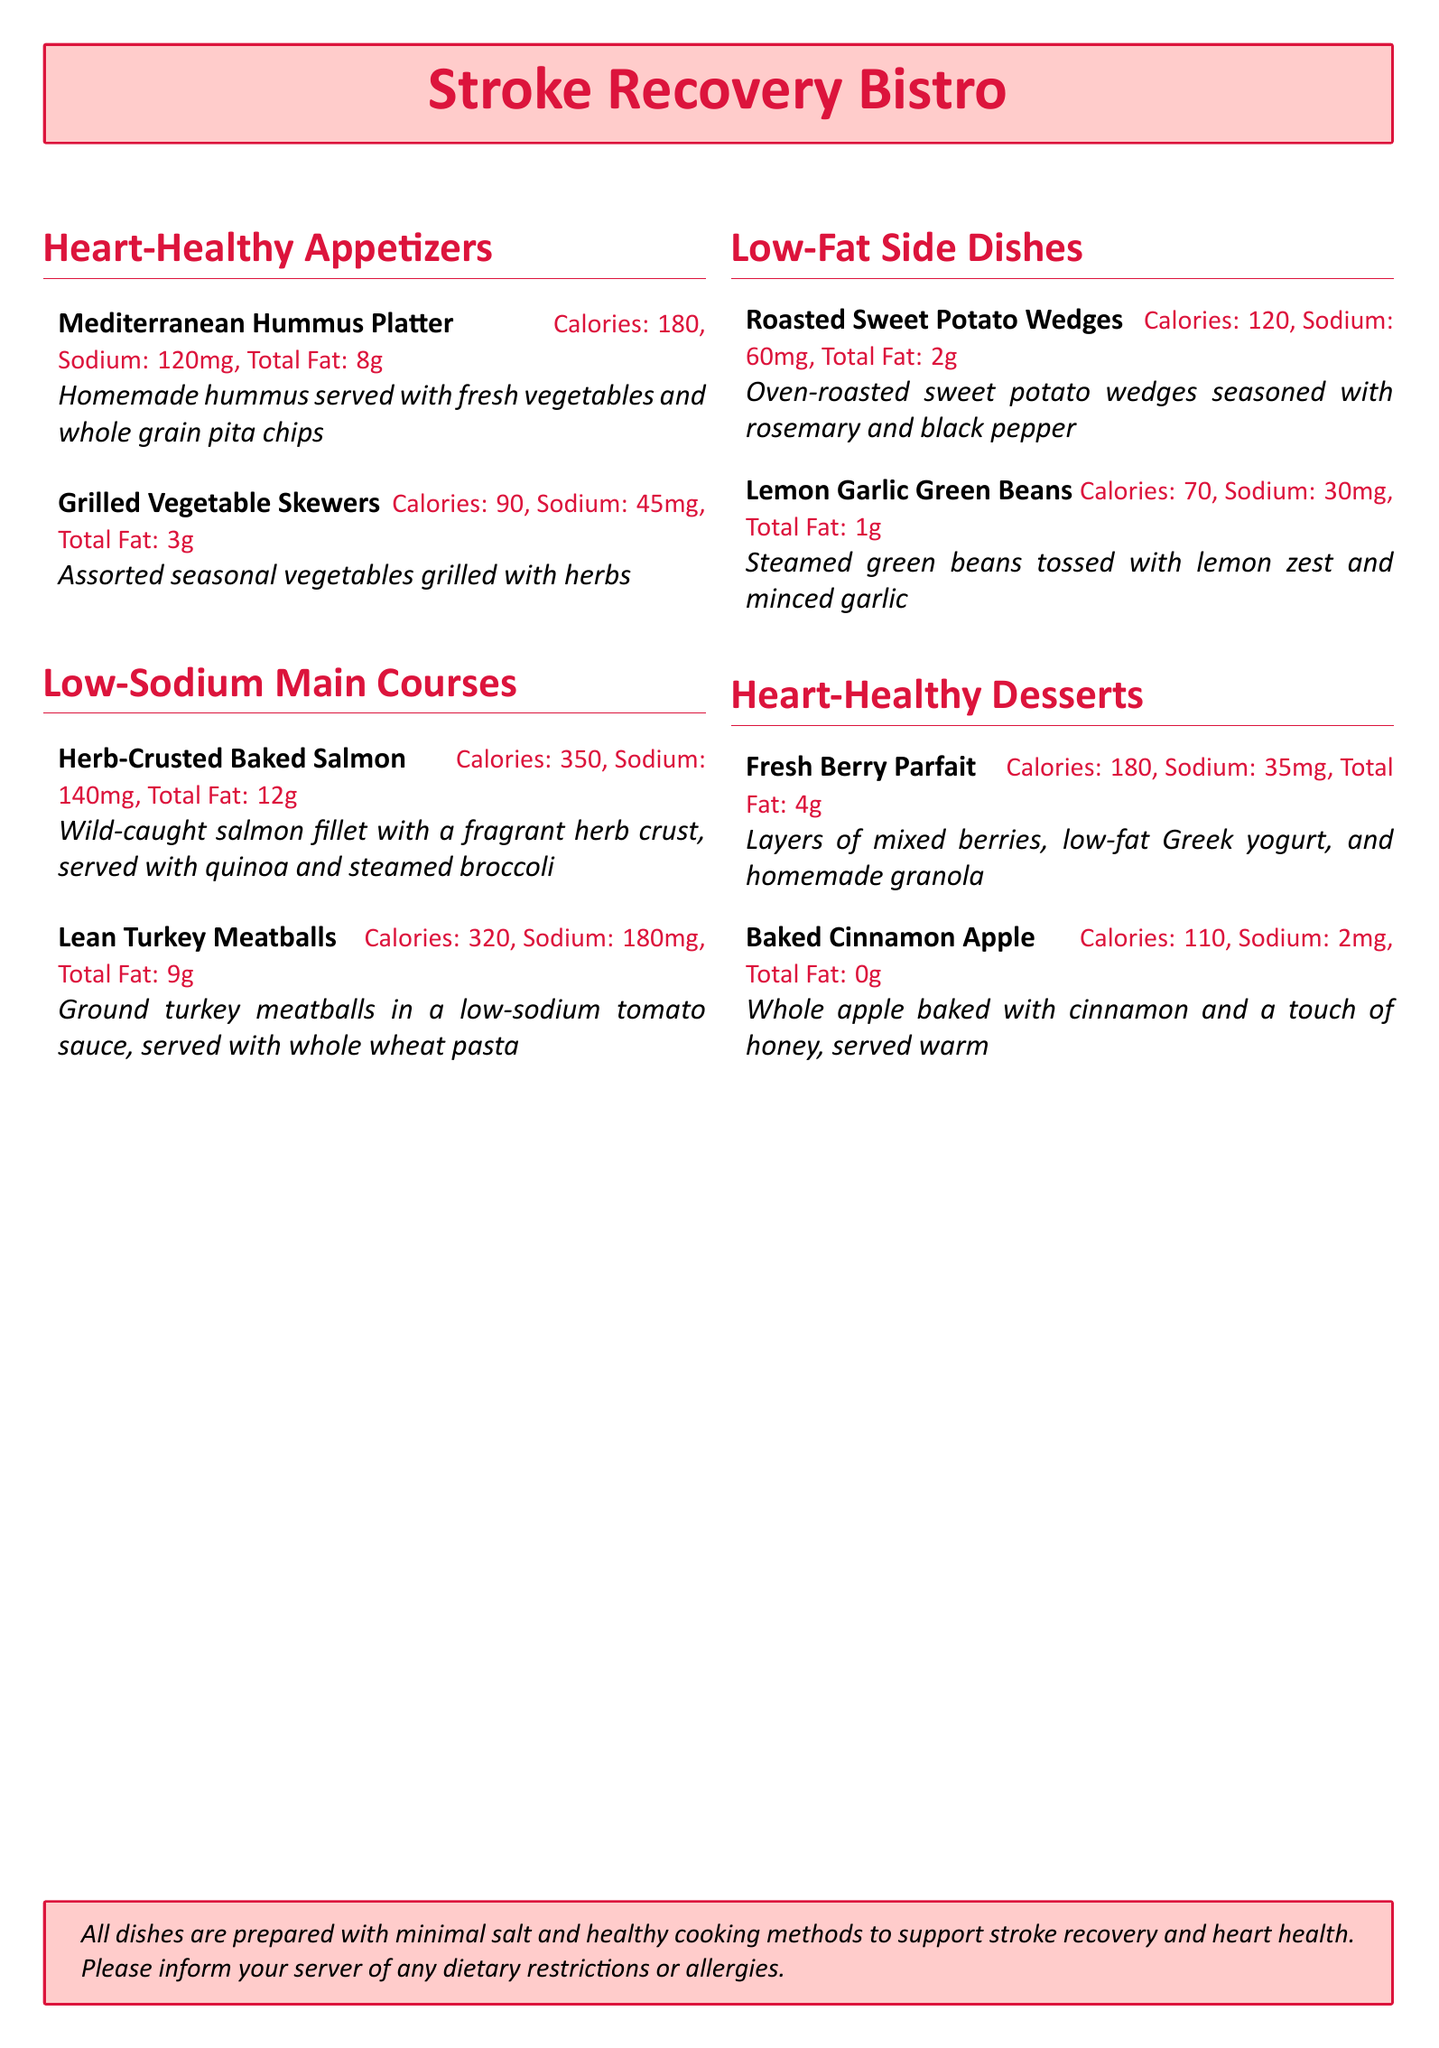What is the calorie count for the Herb-Crusted Baked Salmon? The calorie count for the Herb-Crusted Baked Salmon is mentioned in the section for Low-Sodium Main Courses.
Answer: 350 How much sodium is in the Fresh Berry Parfait? The sodium content for the Fresh Berry Parfait is listed under Heart-Healthy Desserts.
Answer: 35mg What is the total fat in the Baked Cinnamon Apple? The total fat content for the Baked Cinnamon Apple is included under Heart-Healthy Desserts.
Answer: 0g Which appetizer has the highest calorie count? The Mediterranean Hummus Platter has the highest calorie count among the appetizers listed.
Answer: 180 How many grams of total fat are in the Roasted Sweet Potato Wedges? The total fat for the Roasted Sweet Potato Wedges is specified in the Low-Fat Side Dishes section.
Answer: 2g What cooking method is emphasized for all dishes? The document states that all dishes are prepared with minimal salt and healthy cooking methods.
Answer: Healthy cooking methods Which main course features wild-caught salmon? The main course that features wild-caught salmon is identified in the Low-Sodium Main Courses section.
Answer: Herb-Crusted Baked Salmon What dessert includes low-fat Greek yogurt? The dessert that includes low-fat Greek yogurt is specified in the Heart-Healthy Desserts section.
Answer: Fresh Berry Parfait What is the main ingredient in the homemade granola? The question is about the key ingredient in the dessert item Fresh Berry Parfait, which is part of Heart-Healthy Desserts.
Answer: Granola 